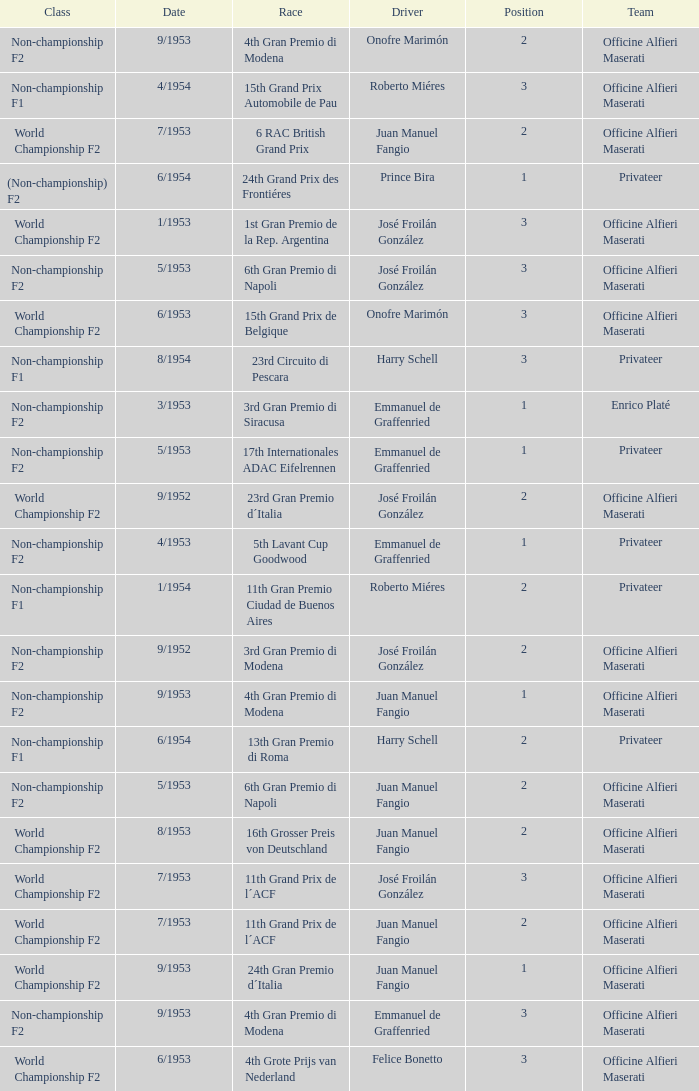What class has the date of 8/1954? Non-championship F1. 